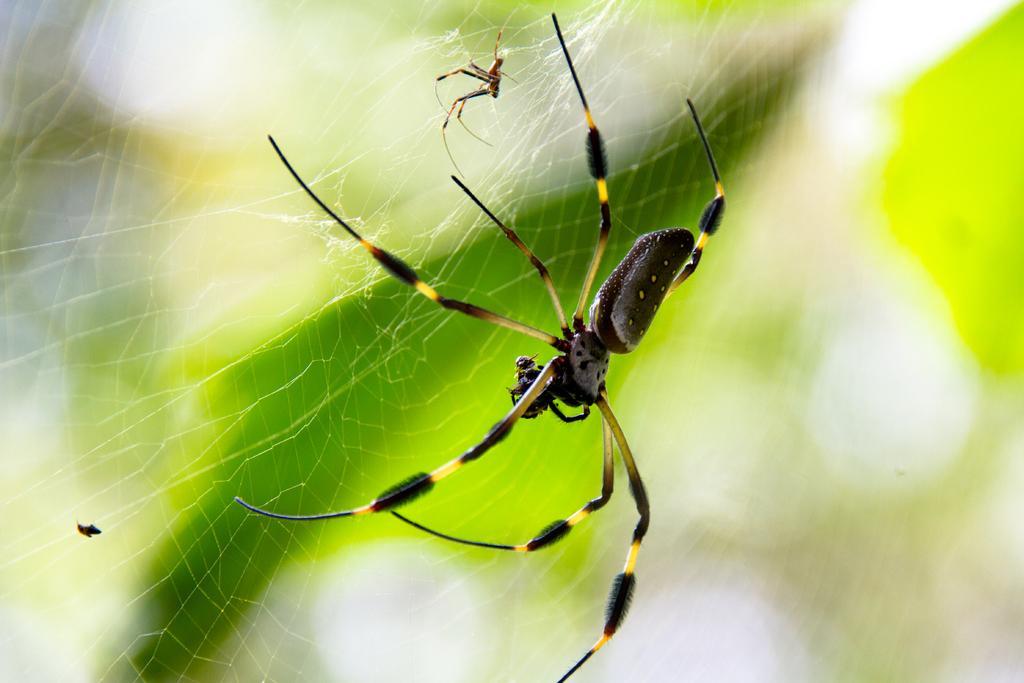Describe this image in one or two sentences. In the middle of this image, there is a spider in black and yellow color combination on a web, on which there is another spider. And the background is blurred. 